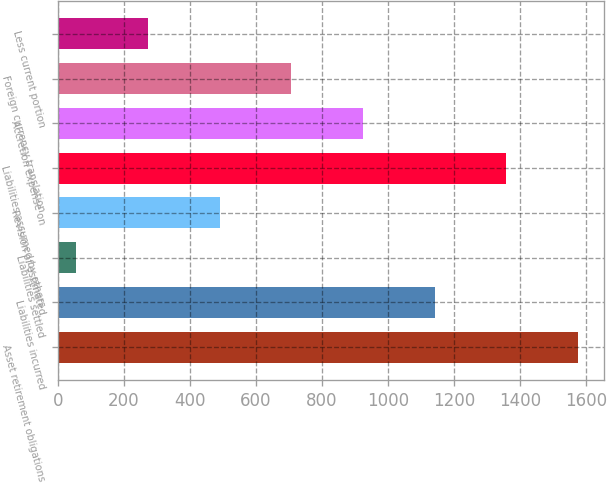<chart> <loc_0><loc_0><loc_500><loc_500><bar_chart><fcel>Asset retirement obligations<fcel>Liabilities incurred<fcel>Liabilities settled<fcel>Revision of estimated<fcel>Liabilities assumed by others<fcel>Accretion expense on<fcel>Foreign currency translation<fcel>Less current portion<nl><fcel>1576.4<fcel>1142<fcel>56<fcel>490.4<fcel>1359.2<fcel>924.8<fcel>707.6<fcel>273.2<nl></chart> 